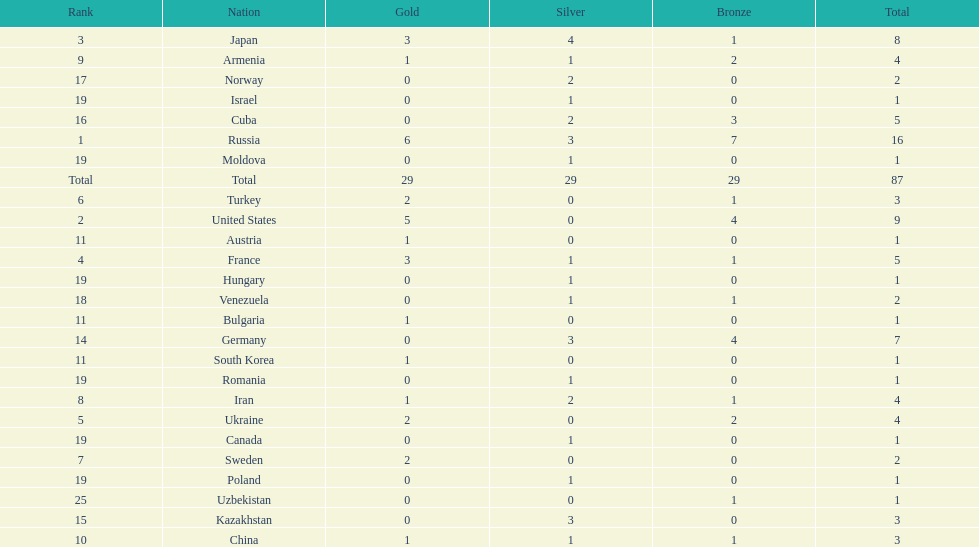Who ranked right after turkey? Sweden. 